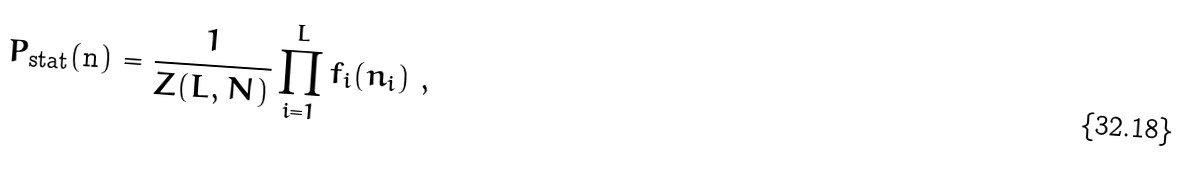Convert formula to latex. <formula><loc_0><loc_0><loc_500><loc_500>P _ { \text {stat} } ( { \mathbf n } ) = \frac { 1 } { Z ( L , N ) } \prod _ { i = 1 } ^ { L } f _ { i } ( n _ { i } ) \ ,</formula> 